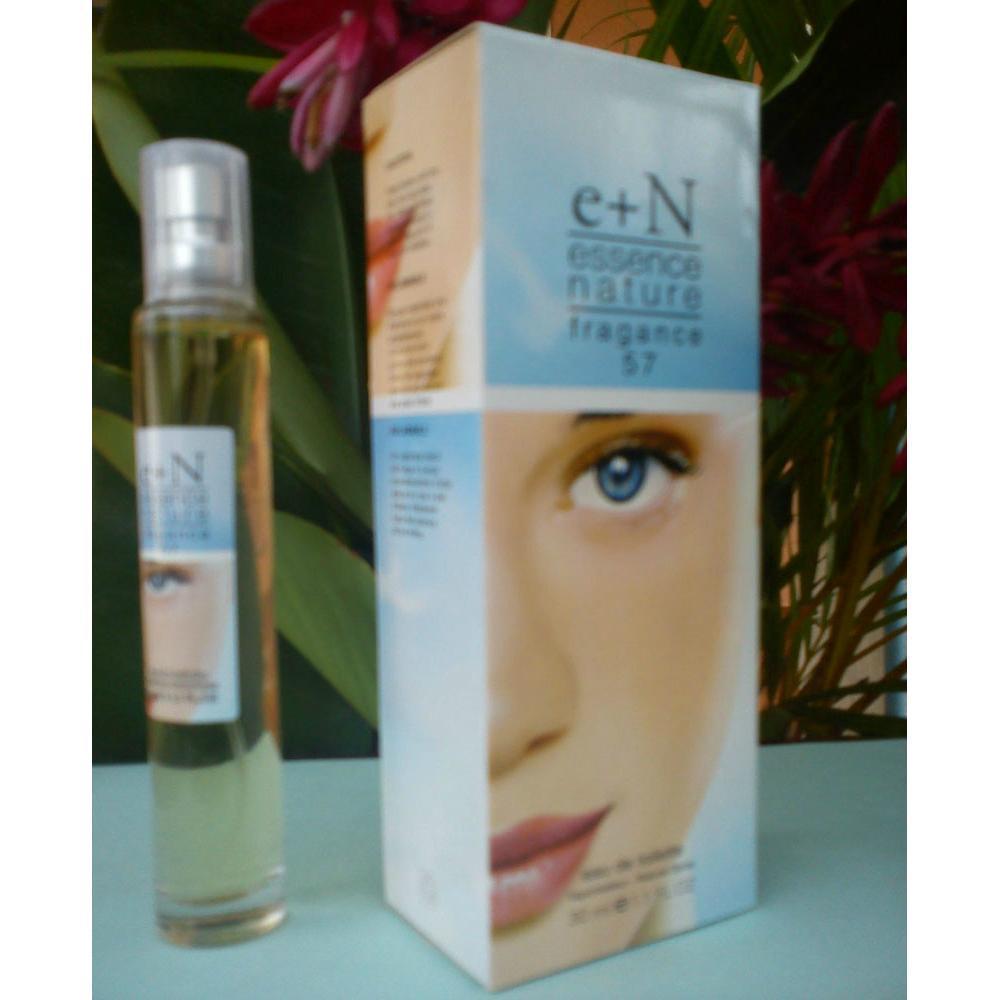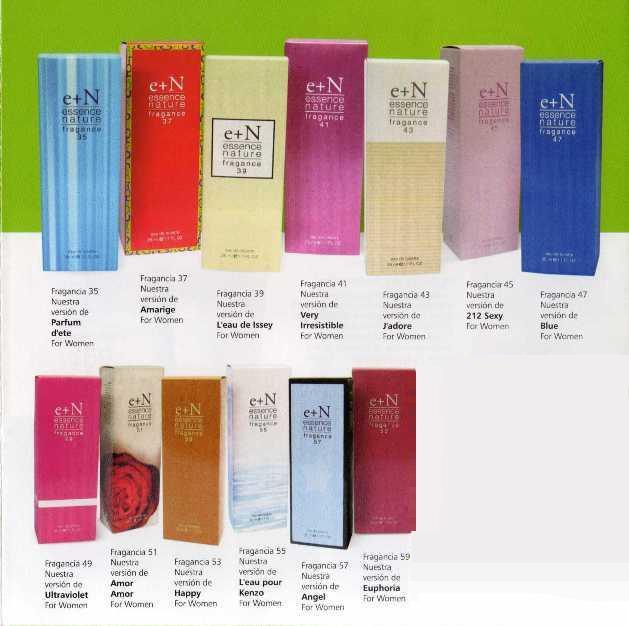The first image is the image on the left, the second image is the image on the right. Analyze the images presented: Is the assertion "The box for the product in the image on the left shows a woman's face." valid? Answer yes or no. Yes. The first image is the image on the left, the second image is the image on the right. Examine the images to the left and right. Is the description "In one image, a single slender spray bottle stands next to a box with a woman's face on it." accurate? Answer yes or no. Yes. The first image is the image on the left, the second image is the image on the right. Considering the images on both sides, is "There is only one tube of product and its box in the image on the left." valid? Answer yes or no. Yes. The first image is the image on the left, the second image is the image on the right. For the images displayed, is the sentence "At least one image shows a spray product standing next to its box." factually correct? Answer yes or no. Yes. 